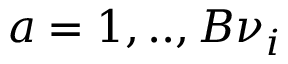<formula> <loc_0><loc_0><loc_500><loc_500>a = 1 , . . , B \nu _ { i }</formula> 